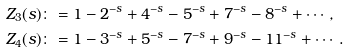<formula> <loc_0><loc_0><loc_500><loc_500>Z _ { 3 } ( s ) & \colon = 1 - 2 ^ { - s } + 4 ^ { - s } - 5 ^ { - s } + 7 ^ { - s } - 8 ^ { - s } + \cdots , \\ Z _ { 4 } ( s ) & \colon = 1 - 3 ^ { - s } + 5 ^ { - s } - 7 ^ { - s } + 9 ^ { - s } - 1 1 ^ { - s } + \cdots .</formula> 